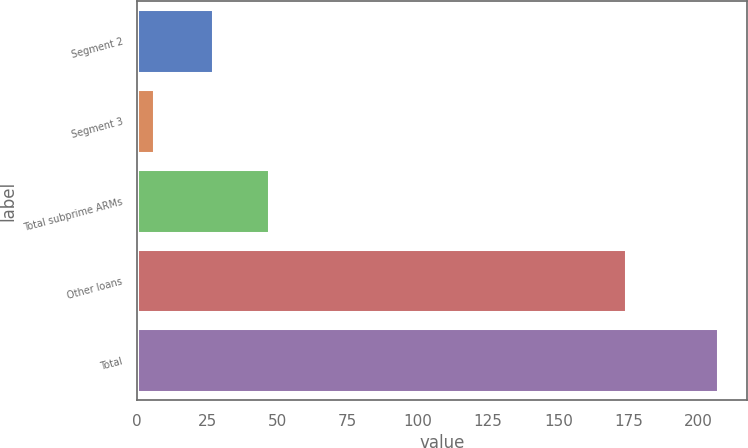<chart> <loc_0><loc_0><loc_500><loc_500><bar_chart><fcel>Segment 2<fcel>Segment 3<fcel>Total subprime ARMs<fcel>Other loans<fcel>Total<nl><fcel>27<fcel>6<fcel>47.1<fcel>174<fcel>207<nl></chart> 